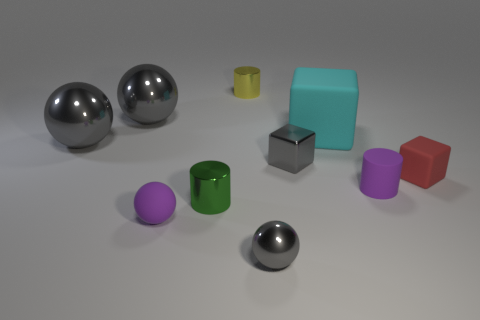Subtract all purple cubes. How many gray balls are left? 3 Subtract 1 spheres. How many spheres are left? 3 Subtract all cyan balls. Subtract all brown cylinders. How many balls are left? 4 Subtract all cylinders. How many objects are left? 7 Add 6 green metal things. How many green metal things exist? 7 Subtract 0 red cylinders. How many objects are left? 10 Subtract all tiny green matte things. Subtract all small gray shiny balls. How many objects are left? 9 Add 5 large spheres. How many large spheres are left? 7 